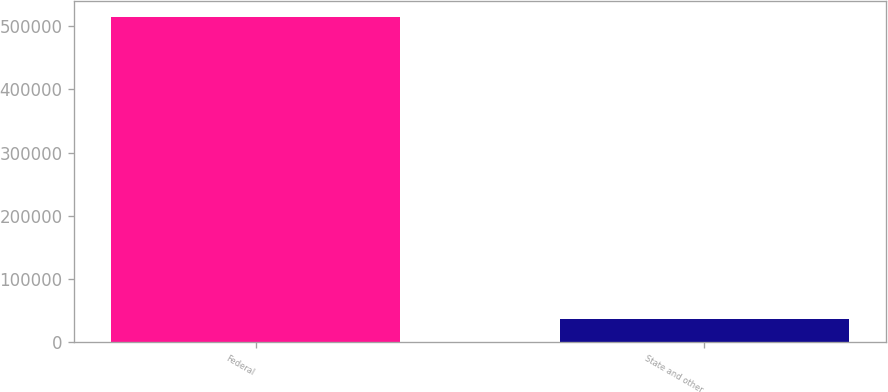Convert chart to OTSL. <chart><loc_0><loc_0><loc_500><loc_500><bar_chart><fcel>Federal<fcel>State and other<nl><fcel>514691<fcel>36223<nl></chart> 